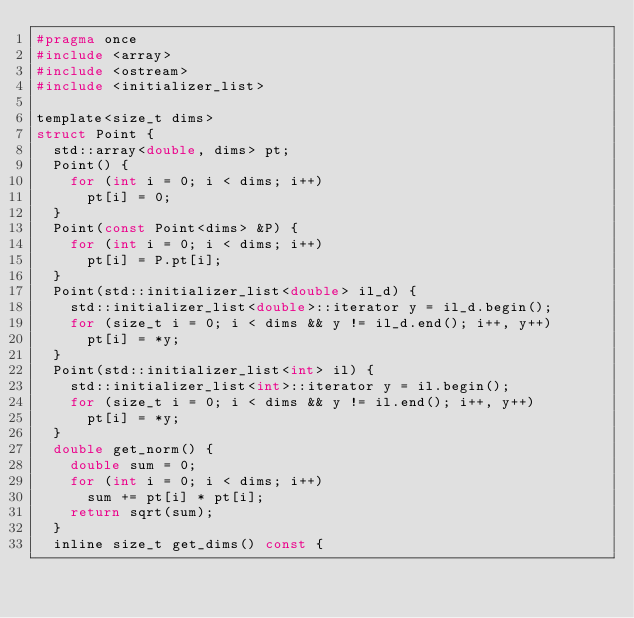Convert code to text. <code><loc_0><loc_0><loc_500><loc_500><_C_>#pragma once
#include <array>
#include <ostream>
#include <initializer_list>

template<size_t dims>
struct Point {
	std::array<double, dims> pt;
	Point() {
		for (int i = 0; i < dims; i++)
			pt[i] = 0;
	}
	Point(const Point<dims> &P) {
		for (int i = 0; i < dims; i++)
			pt[i] = P.pt[i];
	}
	Point(std::initializer_list<double> il_d) {
		std::initializer_list<double>::iterator y = il_d.begin();
		for (size_t i = 0; i < dims && y != il_d.end(); i++, y++)
			pt[i] = *y;
	}
	Point(std::initializer_list<int> il) {
		std::initializer_list<int>::iterator y = il.begin();
		for (size_t i = 0; i < dims && y != il.end(); i++, y++)
			pt[i] = *y;
	}
	double get_norm() {
		double sum = 0;
		for (int i = 0; i < dims; i++)
			sum += pt[i] * pt[i];
		return sqrt(sum);
	}
	inline size_t get_dims() const {</code> 